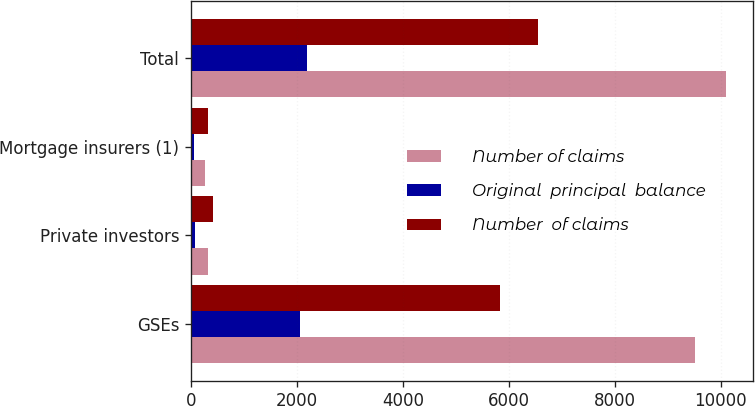Convert chart to OTSL. <chart><loc_0><loc_0><loc_500><loc_500><stacked_bar_chart><ecel><fcel>GSEs<fcel>Private investors<fcel>Mortgage insurers (1)<fcel>Total<nl><fcel>Number of claims<fcel>9512<fcel>321<fcel>268<fcel>10101<nl><fcel>Original  principal  balance<fcel>2063<fcel>73<fcel>58<fcel>2194<nl><fcel>Number  of claims<fcel>5835<fcel>409<fcel>316<fcel>6560<nl></chart> 